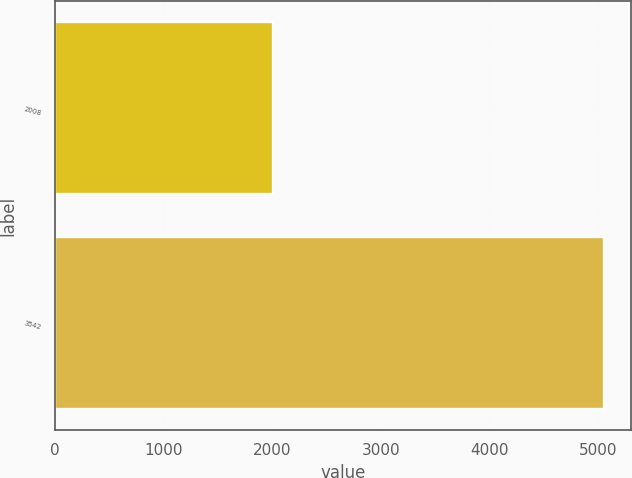Convert chart. <chart><loc_0><loc_0><loc_500><loc_500><bar_chart><fcel>2008<fcel>3542<nl><fcel>2007<fcel>5054<nl></chart> 